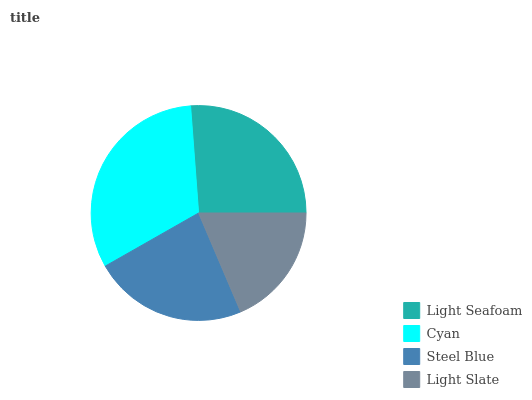Is Light Slate the minimum?
Answer yes or no. Yes. Is Cyan the maximum?
Answer yes or no. Yes. Is Steel Blue the minimum?
Answer yes or no. No. Is Steel Blue the maximum?
Answer yes or no. No. Is Cyan greater than Steel Blue?
Answer yes or no. Yes. Is Steel Blue less than Cyan?
Answer yes or no. Yes. Is Steel Blue greater than Cyan?
Answer yes or no. No. Is Cyan less than Steel Blue?
Answer yes or no. No. Is Light Seafoam the high median?
Answer yes or no. Yes. Is Steel Blue the low median?
Answer yes or no. Yes. Is Light Slate the high median?
Answer yes or no. No. Is Cyan the low median?
Answer yes or no. No. 